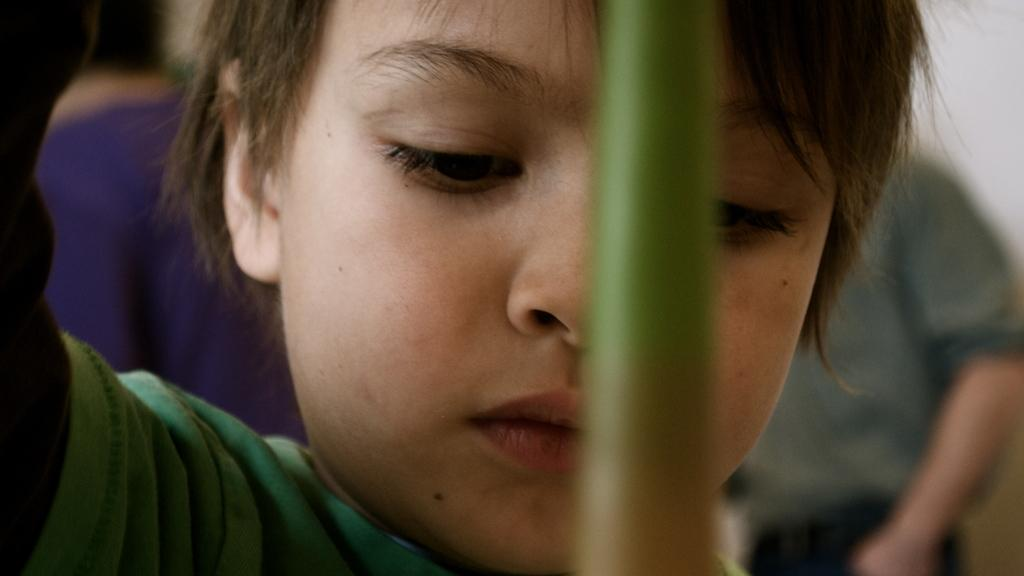How many people are in the image? There are three persons in the image. What is one of the persons doing in the image? One of the persons is holding an object. What is the name of the uncle in the image? There is no mention of an uncle or any names in the image. 